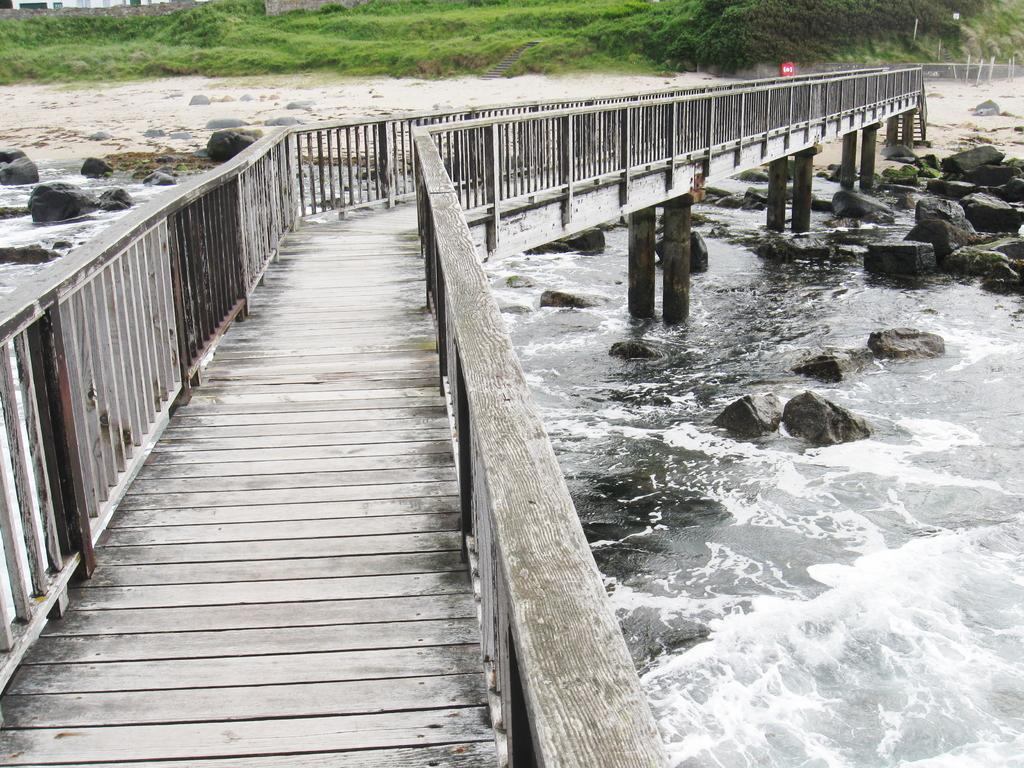What is the main structure in the center of the image? There is a board bridge in the center of the image. What can be seen in the background of the image? There are trees, buildings, poles, and rocks in the background of the image. What is the natural element visible in the image? There is water visible in the image. How does the bridge comb its hair in the image? The bridge does not have hair, so it cannot comb its hair. Additionally, the bridge is an inanimate object and cannot perform actions like combing hair. 